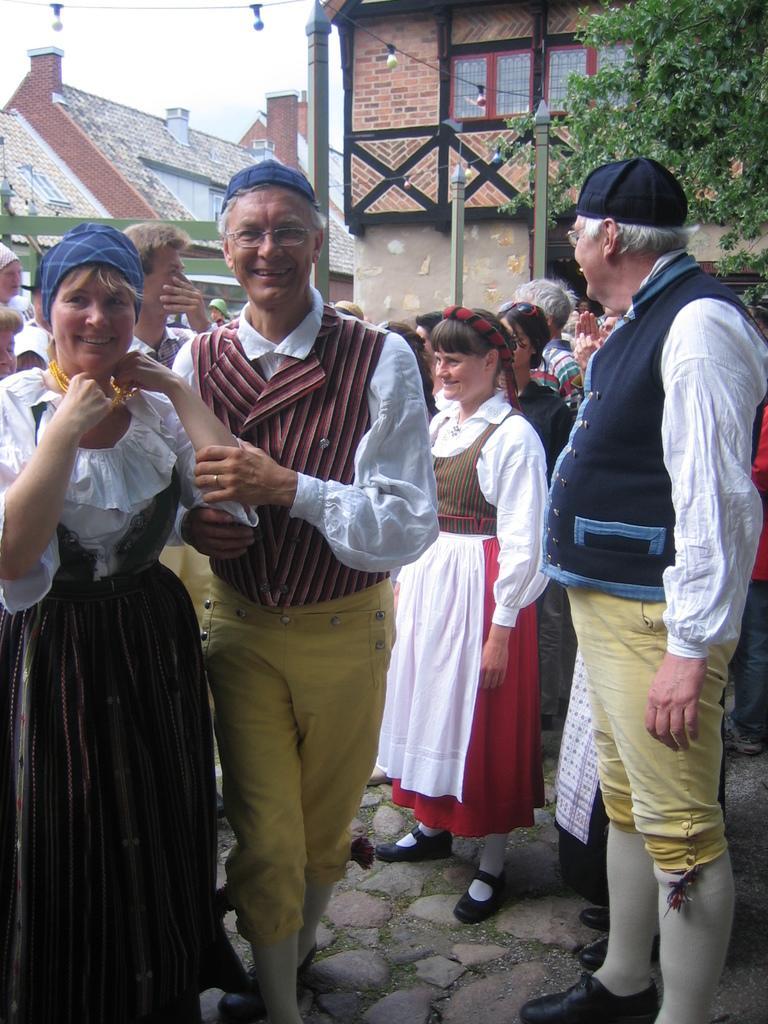Describe this image in one or two sentences. In this image there are a few people standing and having a smile on their face, behind them there are trees and buildings, at the top of the image there are lamps hanging. 